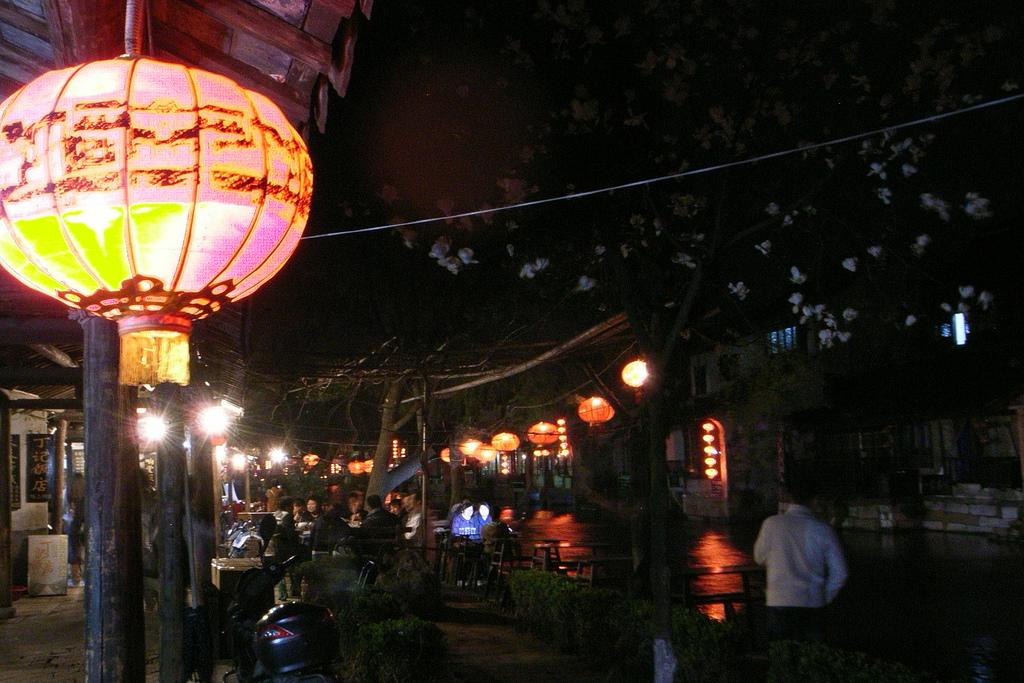What type of decorations can be seen hanging in the image? There are Chinese lanterns hanging in the image. How many people are standing in the image? Two persons are standing in the image. What are the people sitting on in the image? There is a group of people sitting on chairs in the image. What type of furniture is present in the image? Tables are present in the image. What type of structures can be seen in the background of the image? Buildings are visible in the image. What type of vegetation is present in the image? Plants and trees are present in the image. What type of vehicle is present in the image? A motorbike is present in the image. Can you see any fairies flying around the Chinese lanterns in the image? There are no fairies present in the image. What type of protest is taking place in the image? There is no protest depicted in the image. What color is the ink used to write on the motorbike in the image? There is no ink or writing present on the motorbike in the image. 